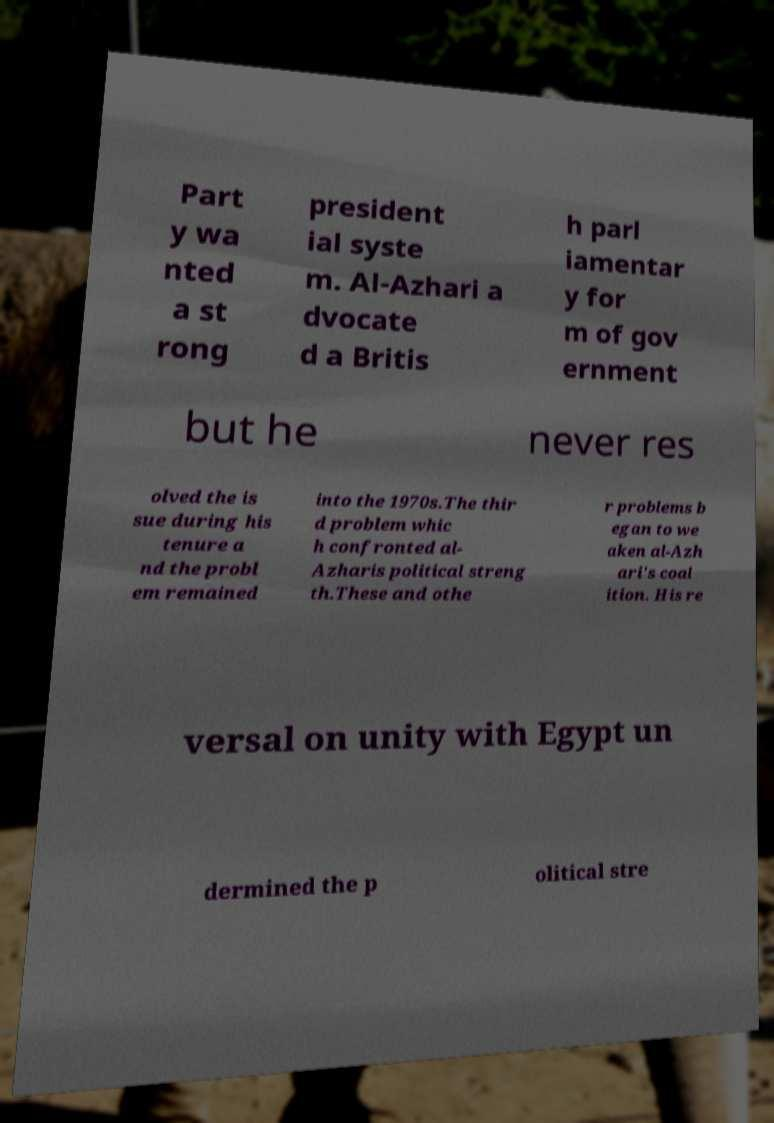Can you read and provide the text displayed in the image?This photo seems to have some interesting text. Can you extract and type it out for me? Part y wa nted a st rong president ial syste m. Al-Azhari a dvocate d a Britis h parl iamentar y for m of gov ernment but he never res olved the is sue during his tenure a nd the probl em remained into the 1970s.The thir d problem whic h confronted al- Azharis political streng th.These and othe r problems b egan to we aken al-Azh ari's coal ition. His re versal on unity with Egypt un dermined the p olitical stre 